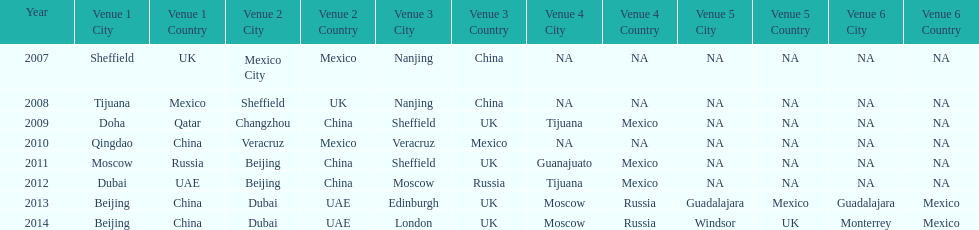Would you mind parsing the complete table? {'header': ['Year', 'Venue 1 City', 'Venue 1 Country', 'Venue 2 City', 'Venue 2 Country', 'Venue 3 City', 'Venue 3 Country', 'Venue 4 City', 'Venue 4 Country', 'Venue 5 City', 'Venue 5 Country', 'Venue 6 City', 'Venue 6 Country'], 'rows': [['2007', 'Sheffield', 'UK', 'Mexico City', 'Mexico', 'Nanjing', 'China', 'NA', 'NA', 'NA', 'NA', 'NA', 'NA'], ['2008', 'Tijuana', 'Mexico', 'Sheffield', 'UK', 'Nanjing', 'China', 'NA', 'NA', 'NA', 'NA', 'NA', 'NA'], ['2009', 'Doha', 'Qatar', 'Changzhou', 'China', 'Sheffield', 'UK', 'Tijuana', 'Mexico', 'NA', 'NA', 'NA', 'NA'], ['2010', 'Qingdao', 'China', 'Veracruz', 'Mexico', 'Veracruz', 'Mexico', 'NA', 'NA', 'NA', 'NA', 'NA', 'NA'], ['2011', 'Moscow', 'Russia', 'Beijing', 'China', 'Sheffield', 'UK', 'Guanajuato', 'Mexico', 'NA', 'NA', 'NA', 'NA'], ['2012', 'Dubai', 'UAE', 'Beijing', 'China', 'Moscow', 'Russia', 'Tijuana', 'Mexico', 'NA', 'NA', 'NA', 'NA'], ['2013', 'Beijing', 'China', 'Dubai', 'UAE', 'Edinburgh', 'UK', 'Moscow', 'Russia', 'Guadalajara', 'Mexico', 'Guadalajara', 'Mexico'], ['2014', 'Beijing', 'China', 'Dubai', 'UAE', 'London', 'UK', 'Moscow', 'Russia', 'Windsor', 'UK', 'Monterrey', 'Mexico']]} Name a year whose second venue was the same as 2011. 2012. 